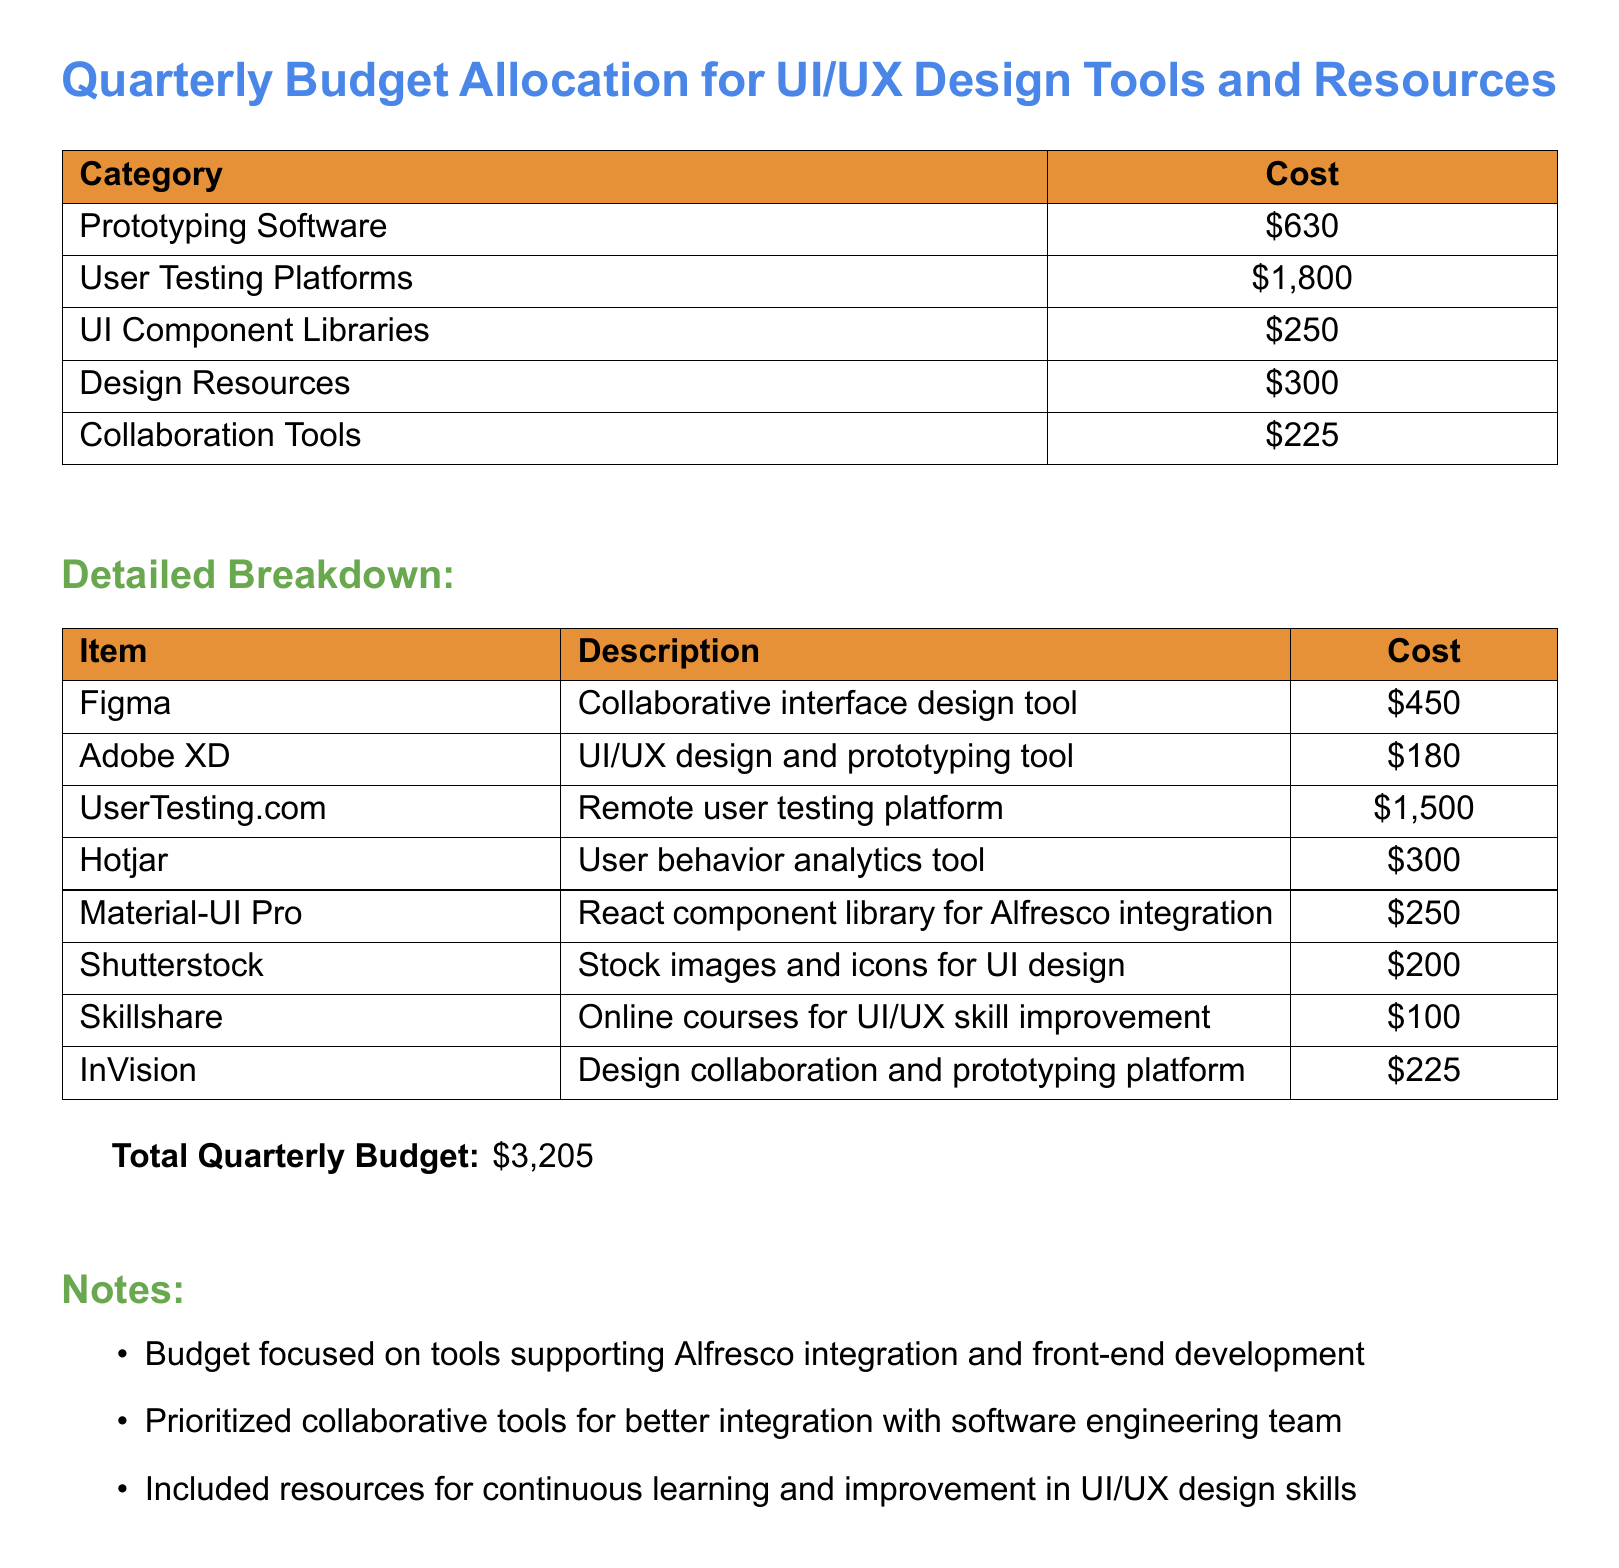What is the total quarterly budget? The total quarterly budget is a summary figure included at the end of the document, which accounts for all allocated costs.
Answer: $3,205 How much is allocated for user testing platforms? The document specifically lists the cost associated with user testing platforms.
Answer: $1,800 What is the cost of Figma? Figma is itemized in the breakdown with its associated cost.
Answer: $450 Which collaboration tool costs $225? The document lists collaboration tools with their prices; this specific tool is mentioned.
Answer: Collaboration Tools What is included in the design resources? The document notes design resources along with their associated costs, detailing specific items.
Answer: $300 What is the cost of the Adobe XD tool? Adobe XD is mentioned in the detailed breakdown, providing its cost.
Answer: $180 How much is spent on Skillshare? The document provides a breakdown of costs for various learning resources, including Skillshare.
Answer: $100 Which prototyping software is mentioned with a cost of $225? The document lists the costs associated with various prototyping platforms.
Answer: InVision What type of courses does Skillshare provide? The document notes that Skillshare is for improving skills in a specific area.
Answer: Online courses for UI/UX skill improvement 